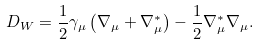<formula> <loc_0><loc_0><loc_500><loc_500>D _ { W } = \frac { 1 } { 2 } \gamma _ { \mu } \left ( \nabla _ { \mu } + \nabla _ { \mu } ^ { * } \right ) - \frac { 1 } { 2 } \nabla _ { \mu } ^ { * } \nabla _ { \mu } .</formula> 